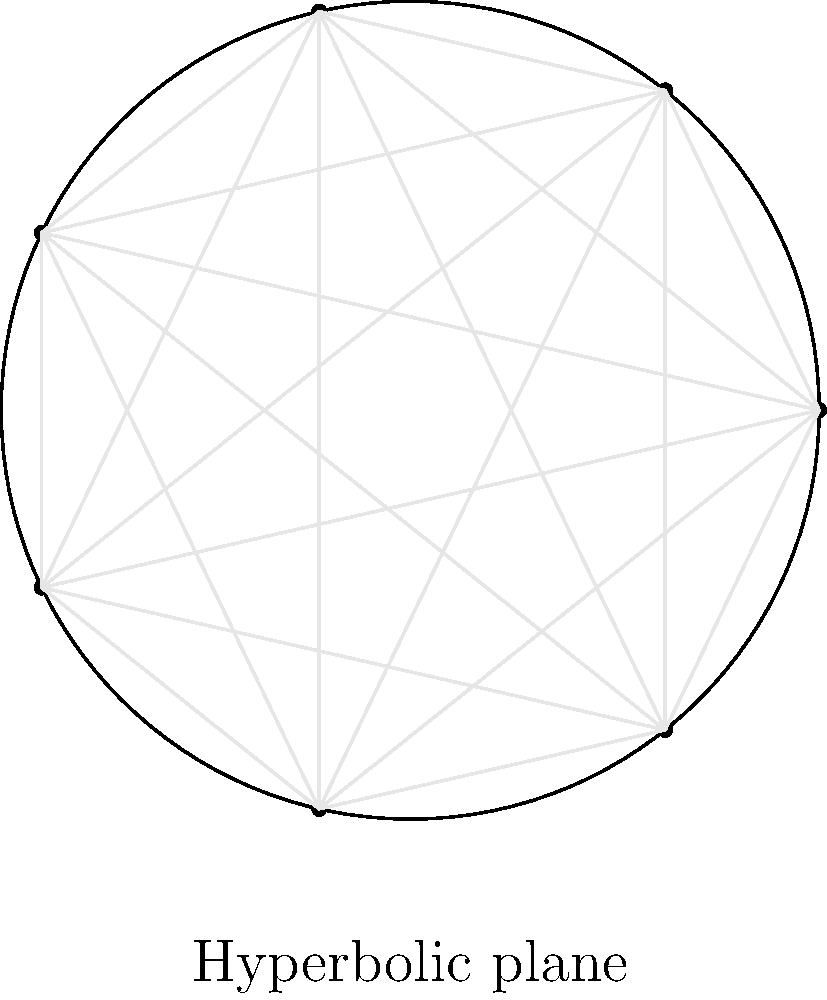In the context of international trade agreements, consider a hyperbolic plane model representing global market connections. A regular heptagon is inscribed in the Poincaré disk model of the hyperbolic plane, as shown in the figure. If the sum of the interior angles of this heptagon is $\frac{5\pi}{7}$, what is the area of the heptagon in terms of $\pi$? Let's approach this step-by-step:

1) In Euclidean geometry, the sum of interior angles of a heptagon would be $(n-2)\pi = 5\pi$. However, in hyperbolic geometry, this sum is less.

2) The area of a hyperbolic polygon is given by the Gauss-Bonnet formula:

   $A = (n-2)\pi - \sum\theta_i$

   where $n$ is the number of sides and $\sum\theta_i$ is the sum of interior angles.

3) We're given that $\sum\theta_i = \frac{5\pi}{7}$

4) Substituting into the formula:

   $A = (7-2)\pi - \frac{5\pi}{7}$

5) Simplify:

   $A = 5\pi - \frac{5\pi}{7}$

6) Find a common denominator:

   $A = \frac{35\pi}{7} - \frac{5\pi}{7} = \frac{30\pi}{7}$

7) Simplify:

   $A = \frac{30\pi}{7} = \frac{30}{7}\pi$

This result shows how global interconnections in trade (represented by the heptagon) can lead to outcomes different from what we might expect in a "flat" world, highlighting the complexity of international economic relationships.
Answer: $\frac{30}{7}\pi$ 